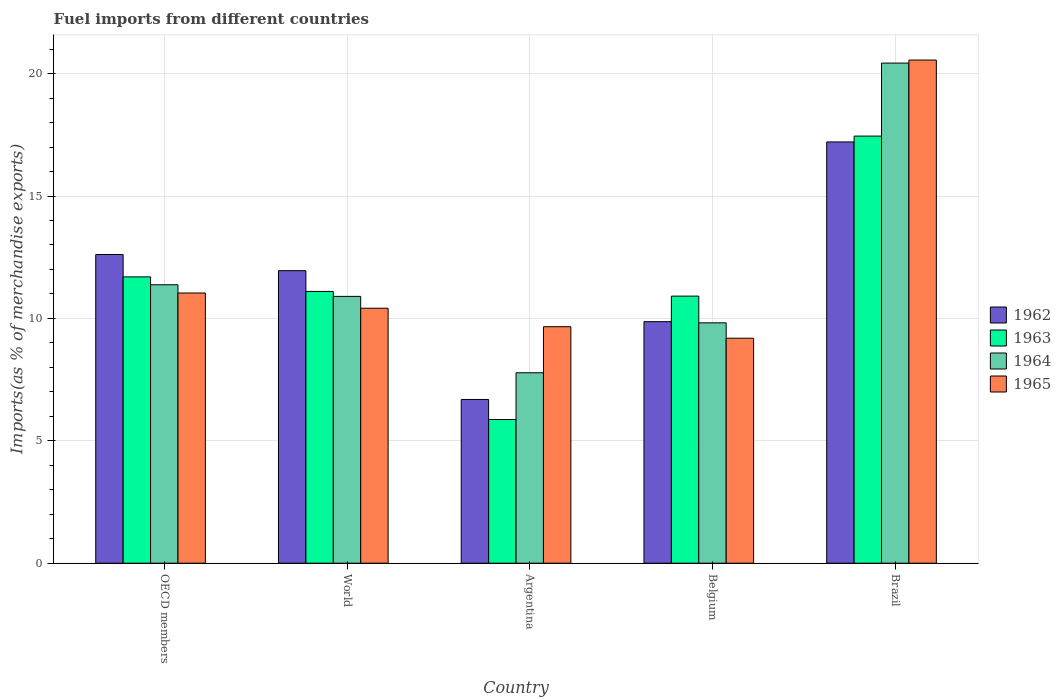How many different coloured bars are there?
Give a very brief answer. 4. Are the number of bars per tick equal to the number of legend labels?
Provide a succinct answer. Yes. Are the number of bars on each tick of the X-axis equal?
Offer a terse response. Yes. How many bars are there on the 3rd tick from the right?
Provide a succinct answer. 4. What is the percentage of imports to different countries in 1962 in Belgium?
Your response must be concise. 9.87. Across all countries, what is the maximum percentage of imports to different countries in 1965?
Provide a succinct answer. 20.55. Across all countries, what is the minimum percentage of imports to different countries in 1965?
Give a very brief answer. 9.19. What is the total percentage of imports to different countries in 1962 in the graph?
Offer a very short reply. 58.33. What is the difference between the percentage of imports to different countries in 1965 in Belgium and that in OECD members?
Your answer should be very brief. -1.85. What is the difference between the percentage of imports to different countries in 1964 in Argentina and the percentage of imports to different countries in 1963 in Brazil?
Keep it short and to the point. -9.67. What is the average percentage of imports to different countries in 1964 per country?
Provide a short and direct response. 12.06. What is the difference between the percentage of imports to different countries of/in 1964 and percentage of imports to different countries of/in 1963 in Belgium?
Your response must be concise. -1.09. What is the ratio of the percentage of imports to different countries in 1964 in OECD members to that in World?
Ensure brevity in your answer.  1.04. Is the difference between the percentage of imports to different countries in 1964 in Argentina and Belgium greater than the difference between the percentage of imports to different countries in 1963 in Argentina and Belgium?
Give a very brief answer. Yes. What is the difference between the highest and the second highest percentage of imports to different countries in 1962?
Give a very brief answer. 5.26. What is the difference between the highest and the lowest percentage of imports to different countries in 1965?
Make the answer very short. 11.36. Is the sum of the percentage of imports to different countries in 1963 in Argentina and Brazil greater than the maximum percentage of imports to different countries in 1964 across all countries?
Make the answer very short. Yes. What does the 3rd bar from the left in Belgium represents?
Give a very brief answer. 1964. What does the 2nd bar from the right in OECD members represents?
Ensure brevity in your answer.  1964. Is it the case that in every country, the sum of the percentage of imports to different countries in 1963 and percentage of imports to different countries in 1962 is greater than the percentage of imports to different countries in 1965?
Offer a very short reply. Yes. How many bars are there?
Make the answer very short. 20. Are all the bars in the graph horizontal?
Provide a succinct answer. No. What is the difference between two consecutive major ticks on the Y-axis?
Make the answer very short. 5. Are the values on the major ticks of Y-axis written in scientific E-notation?
Your answer should be very brief. No. Does the graph contain any zero values?
Your response must be concise. No. Where does the legend appear in the graph?
Your response must be concise. Center right. What is the title of the graph?
Your answer should be compact. Fuel imports from different countries. What is the label or title of the Y-axis?
Your answer should be compact. Imports(as % of merchandise exports). What is the Imports(as % of merchandise exports) in 1962 in OECD members?
Keep it short and to the point. 12.61. What is the Imports(as % of merchandise exports) in 1963 in OECD members?
Your response must be concise. 11.7. What is the Imports(as % of merchandise exports) in 1964 in OECD members?
Provide a short and direct response. 11.37. What is the Imports(as % of merchandise exports) in 1965 in OECD members?
Provide a short and direct response. 11.04. What is the Imports(as % of merchandise exports) of 1962 in World?
Give a very brief answer. 11.95. What is the Imports(as % of merchandise exports) in 1963 in World?
Make the answer very short. 11.1. What is the Imports(as % of merchandise exports) in 1964 in World?
Provide a succinct answer. 10.9. What is the Imports(as % of merchandise exports) of 1965 in World?
Your answer should be very brief. 10.42. What is the Imports(as % of merchandise exports) in 1962 in Argentina?
Give a very brief answer. 6.69. What is the Imports(as % of merchandise exports) in 1963 in Argentina?
Give a very brief answer. 5.87. What is the Imports(as % of merchandise exports) in 1964 in Argentina?
Offer a terse response. 7.78. What is the Imports(as % of merchandise exports) in 1965 in Argentina?
Provide a short and direct response. 9.66. What is the Imports(as % of merchandise exports) of 1962 in Belgium?
Offer a very short reply. 9.87. What is the Imports(as % of merchandise exports) of 1963 in Belgium?
Keep it short and to the point. 10.91. What is the Imports(as % of merchandise exports) of 1964 in Belgium?
Your answer should be very brief. 9.82. What is the Imports(as % of merchandise exports) of 1965 in Belgium?
Offer a very short reply. 9.19. What is the Imports(as % of merchandise exports) of 1962 in Brazil?
Offer a terse response. 17.21. What is the Imports(as % of merchandise exports) in 1963 in Brazil?
Your answer should be compact. 17.45. What is the Imports(as % of merchandise exports) of 1964 in Brazil?
Offer a terse response. 20.43. What is the Imports(as % of merchandise exports) in 1965 in Brazil?
Keep it short and to the point. 20.55. Across all countries, what is the maximum Imports(as % of merchandise exports) of 1962?
Make the answer very short. 17.21. Across all countries, what is the maximum Imports(as % of merchandise exports) in 1963?
Offer a terse response. 17.45. Across all countries, what is the maximum Imports(as % of merchandise exports) in 1964?
Provide a short and direct response. 20.43. Across all countries, what is the maximum Imports(as % of merchandise exports) in 1965?
Offer a very short reply. 20.55. Across all countries, what is the minimum Imports(as % of merchandise exports) in 1962?
Keep it short and to the point. 6.69. Across all countries, what is the minimum Imports(as % of merchandise exports) of 1963?
Keep it short and to the point. 5.87. Across all countries, what is the minimum Imports(as % of merchandise exports) in 1964?
Provide a succinct answer. 7.78. Across all countries, what is the minimum Imports(as % of merchandise exports) in 1965?
Keep it short and to the point. 9.19. What is the total Imports(as % of merchandise exports) in 1962 in the graph?
Your response must be concise. 58.33. What is the total Imports(as % of merchandise exports) in 1963 in the graph?
Give a very brief answer. 57.02. What is the total Imports(as % of merchandise exports) in 1964 in the graph?
Offer a very short reply. 60.3. What is the total Imports(as % of merchandise exports) in 1965 in the graph?
Your answer should be very brief. 60.86. What is the difference between the Imports(as % of merchandise exports) of 1962 in OECD members and that in World?
Your response must be concise. 0.66. What is the difference between the Imports(as % of merchandise exports) in 1963 in OECD members and that in World?
Offer a terse response. 0.59. What is the difference between the Imports(as % of merchandise exports) in 1964 in OECD members and that in World?
Ensure brevity in your answer.  0.48. What is the difference between the Imports(as % of merchandise exports) of 1965 in OECD members and that in World?
Keep it short and to the point. 0.62. What is the difference between the Imports(as % of merchandise exports) in 1962 in OECD members and that in Argentina?
Make the answer very short. 5.92. What is the difference between the Imports(as % of merchandise exports) in 1963 in OECD members and that in Argentina?
Your answer should be very brief. 5.83. What is the difference between the Imports(as % of merchandise exports) in 1964 in OECD members and that in Argentina?
Your response must be concise. 3.59. What is the difference between the Imports(as % of merchandise exports) in 1965 in OECD members and that in Argentina?
Offer a very short reply. 1.38. What is the difference between the Imports(as % of merchandise exports) in 1962 in OECD members and that in Belgium?
Your answer should be compact. 2.74. What is the difference between the Imports(as % of merchandise exports) in 1963 in OECD members and that in Belgium?
Offer a very short reply. 0.79. What is the difference between the Imports(as % of merchandise exports) in 1964 in OECD members and that in Belgium?
Keep it short and to the point. 1.56. What is the difference between the Imports(as % of merchandise exports) in 1965 in OECD members and that in Belgium?
Provide a succinct answer. 1.85. What is the difference between the Imports(as % of merchandise exports) of 1962 in OECD members and that in Brazil?
Make the answer very short. -4.6. What is the difference between the Imports(as % of merchandise exports) of 1963 in OECD members and that in Brazil?
Ensure brevity in your answer.  -5.75. What is the difference between the Imports(as % of merchandise exports) of 1964 in OECD members and that in Brazil?
Make the answer very short. -9.06. What is the difference between the Imports(as % of merchandise exports) in 1965 in OECD members and that in Brazil?
Offer a very short reply. -9.52. What is the difference between the Imports(as % of merchandise exports) in 1962 in World and that in Argentina?
Your answer should be very brief. 5.26. What is the difference between the Imports(as % of merchandise exports) of 1963 in World and that in Argentina?
Make the answer very short. 5.23. What is the difference between the Imports(as % of merchandise exports) of 1964 in World and that in Argentina?
Provide a short and direct response. 3.12. What is the difference between the Imports(as % of merchandise exports) in 1965 in World and that in Argentina?
Keep it short and to the point. 0.76. What is the difference between the Imports(as % of merchandise exports) of 1962 in World and that in Belgium?
Your answer should be very brief. 2.08. What is the difference between the Imports(as % of merchandise exports) in 1963 in World and that in Belgium?
Provide a succinct answer. 0.19. What is the difference between the Imports(as % of merchandise exports) in 1964 in World and that in Belgium?
Make the answer very short. 1.08. What is the difference between the Imports(as % of merchandise exports) of 1965 in World and that in Belgium?
Give a very brief answer. 1.23. What is the difference between the Imports(as % of merchandise exports) in 1962 in World and that in Brazil?
Ensure brevity in your answer.  -5.26. What is the difference between the Imports(as % of merchandise exports) in 1963 in World and that in Brazil?
Ensure brevity in your answer.  -6.34. What is the difference between the Imports(as % of merchandise exports) in 1964 in World and that in Brazil?
Offer a terse response. -9.53. What is the difference between the Imports(as % of merchandise exports) in 1965 in World and that in Brazil?
Provide a succinct answer. -10.14. What is the difference between the Imports(as % of merchandise exports) in 1962 in Argentina and that in Belgium?
Make the answer very short. -3.18. What is the difference between the Imports(as % of merchandise exports) of 1963 in Argentina and that in Belgium?
Provide a short and direct response. -5.04. What is the difference between the Imports(as % of merchandise exports) in 1964 in Argentina and that in Belgium?
Offer a terse response. -2.04. What is the difference between the Imports(as % of merchandise exports) of 1965 in Argentina and that in Belgium?
Provide a succinct answer. 0.47. What is the difference between the Imports(as % of merchandise exports) of 1962 in Argentina and that in Brazil?
Ensure brevity in your answer.  -10.52. What is the difference between the Imports(as % of merchandise exports) of 1963 in Argentina and that in Brazil?
Offer a very short reply. -11.58. What is the difference between the Imports(as % of merchandise exports) in 1964 in Argentina and that in Brazil?
Offer a terse response. -12.65. What is the difference between the Imports(as % of merchandise exports) in 1965 in Argentina and that in Brazil?
Offer a very short reply. -10.89. What is the difference between the Imports(as % of merchandise exports) in 1962 in Belgium and that in Brazil?
Keep it short and to the point. -7.34. What is the difference between the Imports(as % of merchandise exports) of 1963 in Belgium and that in Brazil?
Make the answer very short. -6.54. What is the difference between the Imports(as % of merchandise exports) of 1964 in Belgium and that in Brazil?
Your response must be concise. -10.61. What is the difference between the Imports(as % of merchandise exports) of 1965 in Belgium and that in Brazil?
Give a very brief answer. -11.36. What is the difference between the Imports(as % of merchandise exports) of 1962 in OECD members and the Imports(as % of merchandise exports) of 1963 in World?
Your answer should be very brief. 1.51. What is the difference between the Imports(as % of merchandise exports) in 1962 in OECD members and the Imports(as % of merchandise exports) in 1964 in World?
Ensure brevity in your answer.  1.71. What is the difference between the Imports(as % of merchandise exports) of 1962 in OECD members and the Imports(as % of merchandise exports) of 1965 in World?
Your answer should be very brief. 2.19. What is the difference between the Imports(as % of merchandise exports) of 1963 in OECD members and the Imports(as % of merchandise exports) of 1964 in World?
Ensure brevity in your answer.  0.8. What is the difference between the Imports(as % of merchandise exports) in 1963 in OECD members and the Imports(as % of merchandise exports) in 1965 in World?
Make the answer very short. 1.28. What is the difference between the Imports(as % of merchandise exports) of 1964 in OECD members and the Imports(as % of merchandise exports) of 1965 in World?
Keep it short and to the point. 0.96. What is the difference between the Imports(as % of merchandise exports) in 1962 in OECD members and the Imports(as % of merchandise exports) in 1963 in Argentina?
Offer a very short reply. 6.74. What is the difference between the Imports(as % of merchandise exports) of 1962 in OECD members and the Imports(as % of merchandise exports) of 1964 in Argentina?
Provide a succinct answer. 4.83. What is the difference between the Imports(as % of merchandise exports) of 1962 in OECD members and the Imports(as % of merchandise exports) of 1965 in Argentina?
Ensure brevity in your answer.  2.95. What is the difference between the Imports(as % of merchandise exports) in 1963 in OECD members and the Imports(as % of merchandise exports) in 1964 in Argentina?
Your answer should be very brief. 3.92. What is the difference between the Imports(as % of merchandise exports) of 1963 in OECD members and the Imports(as % of merchandise exports) of 1965 in Argentina?
Ensure brevity in your answer.  2.04. What is the difference between the Imports(as % of merchandise exports) of 1964 in OECD members and the Imports(as % of merchandise exports) of 1965 in Argentina?
Your answer should be very brief. 1.71. What is the difference between the Imports(as % of merchandise exports) in 1962 in OECD members and the Imports(as % of merchandise exports) in 1963 in Belgium?
Keep it short and to the point. 1.7. What is the difference between the Imports(as % of merchandise exports) of 1962 in OECD members and the Imports(as % of merchandise exports) of 1964 in Belgium?
Provide a succinct answer. 2.79. What is the difference between the Imports(as % of merchandise exports) of 1962 in OECD members and the Imports(as % of merchandise exports) of 1965 in Belgium?
Provide a succinct answer. 3.42. What is the difference between the Imports(as % of merchandise exports) of 1963 in OECD members and the Imports(as % of merchandise exports) of 1964 in Belgium?
Offer a very short reply. 1.88. What is the difference between the Imports(as % of merchandise exports) of 1963 in OECD members and the Imports(as % of merchandise exports) of 1965 in Belgium?
Give a very brief answer. 2.51. What is the difference between the Imports(as % of merchandise exports) in 1964 in OECD members and the Imports(as % of merchandise exports) in 1965 in Belgium?
Your answer should be compact. 2.18. What is the difference between the Imports(as % of merchandise exports) in 1962 in OECD members and the Imports(as % of merchandise exports) in 1963 in Brazil?
Ensure brevity in your answer.  -4.84. What is the difference between the Imports(as % of merchandise exports) in 1962 in OECD members and the Imports(as % of merchandise exports) in 1964 in Brazil?
Offer a terse response. -7.82. What is the difference between the Imports(as % of merchandise exports) of 1962 in OECD members and the Imports(as % of merchandise exports) of 1965 in Brazil?
Keep it short and to the point. -7.94. What is the difference between the Imports(as % of merchandise exports) in 1963 in OECD members and the Imports(as % of merchandise exports) in 1964 in Brazil?
Your answer should be very brief. -8.73. What is the difference between the Imports(as % of merchandise exports) in 1963 in OECD members and the Imports(as % of merchandise exports) in 1965 in Brazil?
Your response must be concise. -8.86. What is the difference between the Imports(as % of merchandise exports) in 1964 in OECD members and the Imports(as % of merchandise exports) in 1965 in Brazil?
Offer a very short reply. -9.18. What is the difference between the Imports(as % of merchandise exports) of 1962 in World and the Imports(as % of merchandise exports) of 1963 in Argentina?
Offer a terse response. 6.08. What is the difference between the Imports(as % of merchandise exports) in 1962 in World and the Imports(as % of merchandise exports) in 1964 in Argentina?
Ensure brevity in your answer.  4.17. What is the difference between the Imports(as % of merchandise exports) in 1962 in World and the Imports(as % of merchandise exports) in 1965 in Argentina?
Offer a terse response. 2.29. What is the difference between the Imports(as % of merchandise exports) in 1963 in World and the Imports(as % of merchandise exports) in 1964 in Argentina?
Provide a short and direct response. 3.32. What is the difference between the Imports(as % of merchandise exports) of 1963 in World and the Imports(as % of merchandise exports) of 1965 in Argentina?
Offer a very short reply. 1.44. What is the difference between the Imports(as % of merchandise exports) of 1964 in World and the Imports(as % of merchandise exports) of 1965 in Argentina?
Offer a very short reply. 1.24. What is the difference between the Imports(as % of merchandise exports) of 1962 in World and the Imports(as % of merchandise exports) of 1963 in Belgium?
Provide a short and direct response. 1.04. What is the difference between the Imports(as % of merchandise exports) in 1962 in World and the Imports(as % of merchandise exports) in 1964 in Belgium?
Your answer should be very brief. 2.13. What is the difference between the Imports(as % of merchandise exports) in 1962 in World and the Imports(as % of merchandise exports) in 1965 in Belgium?
Ensure brevity in your answer.  2.76. What is the difference between the Imports(as % of merchandise exports) of 1963 in World and the Imports(as % of merchandise exports) of 1964 in Belgium?
Make the answer very short. 1.28. What is the difference between the Imports(as % of merchandise exports) in 1963 in World and the Imports(as % of merchandise exports) in 1965 in Belgium?
Give a very brief answer. 1.91. What is the difference between the Imports(as % of merchandise exports) of 1964 in World and the Imports(as % of merchandise exports) of 1965 in Belgium?
Ensure brevity in your answer.  1.71. What is the difference between the Imports(as % of merchandise exports) in 1962 in World and the Imports(as % of merchandise exports) in 1963 in Brazil?
Your answer should be very brief. -5.5. What is the difference between the Imports(as % of merchandise exports) of 1962 in World and the Imports(as % of merchandise exports) of 1964 in Brazil?
Offer a very short reply. -8.48. What is the difference between the Imports(as % of merchandise exports) in 1962 in World and the Imports(as % of merchandise exports) in 1965 in Brazil?
Provide a succinct answer. -8.6. What is the difference between the Imports(as % of merchandise exports) in 1963 in World and the Imports(as % of merchandise exports) in 1964 in Brazil?
Your answer should be very brief. -9.33. What is the difference between the Imports(as % of merchandise exports) in 1963 in World and the Imports(as % of merchandise exports) in 1965 in Brazil?
Keep it short and to the point. -9.45. What is the difference between the Imports(as % of merchandise exports) of 1964 in World and the Imports(as % of merchandise exports) of 1965 in Brazil?
Ensure brevity in your answer.  -9.66. What is the difference between the Imports(as % of merchandise exports) of 1962 in Argentina and the Imports(as % of merchandise exports) of 1963 in Belgium?
Your answer should be compact. -4.22. What is the difference between the Imports(as % of merchandise exports) in 1962 in Argentina and the Imports(as % of merchandise exports) in 1964 in Belgium?
Ensure brevity in your answer.  -3.13. What is the difference between the Imports(as % of merchandise exports) in 1962 in Argentina and the Imports(as % of merchandise exports) in 1965 in Belgium?
Offer a very short reply. -2.5. What is the difference between the Imports(as % of merchandise exports) of 1963 in Argentina and the Imports(as % of merchandise exports) of 1964 in Belgium?
Make the answer very short. -3.95. What is the difference between the Imports(as % of merchandise exports) in 1963 in Argentina and the Imports(as % of merchandise exports) in 1965 in Belgium?
Offer a terse response. -3.32. What is the difference between the Imports(as % of merchandise exports) in 1964 in Argentina and the Imports(as % of merchandise exports) in 1965 in Belgium?
Offer a terse response. -1.41. What is the difference between the Imports(as % of merchandise exports) of 1962 in Argentina and the Imports(as % of merchandise exports) of 1963 in Brazil?
Offer a very short reply. -10.76. What is the difference between the Imports(as % of merchandise exports) of 1962 in Argentina and the Imports(as % of merchandise exports) of 1964 in Brazil?
Your response must be concise. -13.74. What is the difference between the Imports(as % of merchandise exports) of 1962 in Argentina and the Imports(as % of merchandise exports) of 1965 in Brazil?
Ensure brevity in your answer.  -13.87. What is the difference between the Imports(as % of merchandise exports) in 1963 in Argentina and the Imports(as % of merchandise exports) in 1964 in Brazil?
Your response must be concise. -14.56. What is the difference between the Imports(as % of merchandise exports) in 1963 in Argentina and the Imports(as % of merchandise exports) in 1965 in Brazil?
Provide a succinct answer. -14.68. What is the difference between the Imports(as % of merchandise exports) in 1964 in Argentina and the Imports(as % of merchandise exports) in 1965 in Brazil?
Make the answer very short. -12.77. What is the difference between the Imports(as % of merchandise exports) in 1962 in Belgium and the Imports(as % of merchandise exports) in 1963 in Brazil?
Make the answer very short. -7.58. What is the difference between the Imports(as % of merchandise exports) in 1962 in Belgium and the Imports(as % of merchandise exports) in 1964 in Brazil?
Ensure brevity in your answer.  -10.56. What is the difference between the Imports(as % of merchandise exports) in 1962 in Belgium and the Imports(as % of merchandise exports) in 1965 in Brazil?
Ensure brevity in your answer.  -10.69. What is the difference between the Imports(as % of merchandise exports) in 1963 in Belgium and the Imports(as % of merchandise exports) in 1964 in Brazil?
Keep it short and to the point. -9.52. What is the difference between the Imports(as % of merchandise exports) in 1963 in Belgium and the Imports(as % of merchandise exports) in 1965 in Brazil?
Provide a short and direct response. -9.64. What is the difference between the Imports(as % of merchandise exports) in 1964 in Belgium and the Imports(as % of merchandise exports) in 1965 in Brazil?
Give a very brief answer. -10.74. What is the average Imports(as % of merchandise exports) in 1962 per country?
Provide a succinct answer. 11.66. What is the average Imports(as % of merchandise exports) in 1963 per country?
Ensure brevity in your answer.  11.4. What is the average Imports(as % of merchandise exports) of 1964 per country?
Offer a terse response. 12.06. What is the average Imports(as % of merchandise exports) in 1965 per country?
Offer a terse response. 12.17. What is the difference between the Imports(as % of merchandise exports) of 1962 and Imports(as % of merchandise exports) of 1963 in OECD members?
Offer a terse response. 0.91. What is the difference between the Imports(as % of merchandise exports) of 1962 and Imports(as % of merchandise exports) of 1964 in OECD members?
Your answer should be very brief. 1.24. What is the difference between the Imports(as % of merchandise exports) of 1962 and Imports(as % of merchandise exports) of 1965 in OECD members?
Your answer should be very brief. 1.57. What is the difference between the Imports(as % of merchandise exports) of 1963 and Imports(as % of merchandise exports) of 1964 in OECD members?
Your response must be concise. 0.32. What is the difference between the Imports(as % of merchandise exports) in 1963 and Imports(as % of merchandise exports) in 1965 in OECD members?
Give a very brief answer. 0.66. What is the difference between the Imports(as % of merchandise exports) of 1964 and Imports(as % of merchandise exports) of 1965 in OECD members?
Provide a succinct answer. 0.34. What is the difference between the Imports(as % of merchandise exports) of 1962 and Imports(as % of merchandise exports) of 1963 in World?
Your response must be concise. 0.85. What is the difference between the Imports(as % of merchandise exports) in 1962 and Imports(as % of merchandise exports) in 1964 in World?
Provide a short and direct response. 1.05. What is the difference between the Imports(as % of merchandise exports) of 1962 and Imports(as % of merchandise exports) of 1965 in World?
Offer a terse response. 1.53. What is the difference between the Imports(as % of merchandise exports) of 1963 and Imports(as % of merchandise exports) of 1964 in World?
Your answer should be very brief. 0.2. What is the difference between the Imports(as % of merchandise exports) of 1963 and Imports(as % of merchandise exports) of 1965 in World?
Provide a short and direct response. 0.69. What is the difference between the Imports(as % of merchandise exports) in 1964 and Imports(as % of merchandise exports) in 1965 in World?
Offer a very short reply. 0.48. What is the difference between the Imports(as % of merchandise exports) in 1962 and Imports(as % of merchandise exports) in 1963 in Argentina?
Keep it short and to the point. 0.82. What is the difference between the Imports(as % of merchandise exports) in 1962 and Imports(as % of merchandise exports) in 1964 in Argentina?
Offer a very short reply. -1.09. What is the difference between the Imports(as % of merchandise exports) in 1962 and Imports(as % of merchandise exports) in 1965 in Argentina?
Give a very brief answer. -2.97. What is the difference between the Imports(as % of merchandise exports) in 1963 and Imports(as % of merchandise exports) in 1964 in Argentina?
Your answer should be very brief. -1.91. What is the difference between the Imports(as % of merchandise exports) in 1963 and Imports(as % of merchandise exports) in 1965 in Argentina?
Offer a terse response. -3.79. What is the difference between the Imports(as % of merchandise exports) in 1964 and Imports(as % of merchandise exports) in 1965 in Argentina?
Keep it short and to the point. -1.88. What is the difference between the Imports(as % of merchandise exports) in 1962 and Imports(as % of merchandise exports) in 1963 in Belgium?
Your answer should be very brief. -1.04. What is the difference between the Imports(as % of merchandise exports) of 1962 and Imports(as % of merchandise exports) of 1964 in Belgium?
Offer a very short reply. 0.05. What is the difference between the Imports(as % of merchandise exports) in 1962 and Imports(as % of merchandise exports) in 1965 in Belgium?
Offer a terse response. 0.68. What is the difference between the Imports(as % of merchandise exports) in 1963 and Imports(as % of merchandise exports) in 1964 in Belgium?
Make the answer very short. 1.09. What is the difference between the Imports(as % of merchandise exports) in 1963 and Imports(as % of merchandise exports) in 1965 in Belgium?
Ensure brevity in your answer.  1.72. What is the difference between the Imports(as % of merchandise exports) in 1964 and Imports(as % of merchandise exports) in 1965 in Belgium?
Provide a succinct answer. 0.63. What is the difference between the Imports(as % of merchandise exports) of 1962 and Imports(as % of merchandise exports) of 1963 in Brazil?
Make the answer very short. -0.24. What is the difference between the Imports(as % of merchandise exports) of 1962 and Imports(as % of merchandise exports) of 1964 in Brazil?
Offer a terse response. -3.22. What is the difference between the Imports(as % of merchandise exports) in 1962 and Imports(as % of merchandise exports) in 1965 in Brazil?
Your response must be concise. -3.35. What is the difference between the Imports(as % of merchandise exports) of 1963 and Imports(as % of merchandise exports) of 1964 in Brazil?
Keep it short and to the point. -2.98. What is the difference between the Imports(as % of merchandise exports) in 1963 and Imports(as % of merchandise exports) in 1965 in Brazil?
Keep it short and to the point. -3.11. What is the difference between the Imports(as % of merchandise exports) in 1964 and Imports(as % of merchandise exports) in 1965 in Brazil?
Offer a very short reply. -0.12. What is the ratio of the Imports(as % of merchandise exports) of 1962 in OECD members to that in World?
Your response must be concise. 1.06. What is the ratio of the Imports(as % of merchandise exports) in 1963 in OECD members to that in World?
Offer a very short reply. 1.05. What is the ratio of the Imports(as % of merchandise exports) in 1964 in OECD members to that in World?
Provide a succinct answer. 1.04. What is the ratio of the Imports(as % of merchandise exports) of 1965 in OECD members to that in World?
Keep it short and to the point. 1.06. What is the ratio of the Imports(as % of merchandise exports) of 1962 in OECD members to that in Argentina?
Provide a short and direct response. 1.89. What is the ratio of the Imports(as % of merchandise exports) in 1963 in OECD members to that in Argentina?
Provide a succinct answer. 1.99. What is the ratio of the Imports(as % of merchandise exports) in 1964 in OECD members to that in Argentina?
Your response must be concise. 1.46. What is the ratio of the Imports(as % of merchandise exports) of 1965 in OECD members to that in Argentina?
Make the answer very short. 1.14. What is the ratio of the Imports(as % of merchandise exports) of 1962 in OECD members to that in Belgium?
Your answer should be compact. 1.28. What is the ratio of the Imports(as % of merchandise exports) in 1963 in OECD members to that in Belgium?
Offer a very short reply. 1.07. What is the ratio of the Imports(as % of merchandise exports) in 1964 in OECD members to that in Belgium?
Give a very brief answer. 1.16. What is the ratio of the Imports(as % of merchandise exports) in 1965 in OECD members to that in Belgium?
Your answer should be very brief. 1.2. What is the ratio of the Imports(as % of merchandise exports) in 1962 in OECD members to that in Brazil?
Provide a succinct answer. 0.73. What is the ratio of the Imports(as % of merchandise exports) in 1963 in OECD members to that in Brazil?
Offer a very short reply. 0.67. What is the ratio of the Imports(as % of merchandise exports) in 1964 in OECD members to that in Brazil?
Offer a very short reply. 0.56. What is the ratio of the Imports(as % of merchandise exports) in 1965 in OECD members to that in Brazil?
Offer a very short reply. 0.54. What is the ratio of the Imports(as % of merchandise exports) in 1962 in World to that in Argentina?
Make the answer very short. 1.79. What is the ratio of the Imports(as % of merchandise exports) in 1963 in World to that in Argentina?
Ensure brevity in your answer.  1.89. What is the ratio of the Imports(as % of merchandise exports) of 1964 in World to that in Argentina?
Keep it short and to the point. 1.4. What is the ratio of the Imports(as % of merchandise exports) in 1965 in World to that in Argentina?
Give a very brief answer. 1.08. What is the ratio of the Imports(as % of merchandise exports) of 1962 in World to that in Belgium?
Your answer should be compact. 1.21. What is the ratio of the Imports(as % of merchandise exports) of 1963 in World to that in Belgium?
Offer a terse response. 1.02. What is the ratio of the Imports(as % of merchandise exports) in 1964 in World to that in Belgium?
Keep it short and to the point. 1.11. What is the ratio of the Imports(as % of merchandise exports) of 1965 in World to that in Belgium?
Make the answer very short. 1.13. What is the ratio of the Imports(as % of merchandise exports) of 1962 in World to that in Brazil?
Keep it short and to the point. 0.69. What is the ratio of the Imports(as % of merchandise exports) in 1963 in World to that in Brazil?
Your response must be concise. 0.64. What is the ratio of the Imports(as % of merchandise exports) of 1964 in World to that in Brazil?
Provide a short and direct response. 0.53. What is the ratio of the Imports(as % of merchandise exports) in 1965 in World to that in Brazil?
Offer a very short reply. 0.51. What is the ratio of the Imports(as % of merchandise exports) in 1962 in Argentina to that in Belgium?
Your response must be concise. 0.68. What is the ratio of the Imports(as % of merchandise exports) of 1963 in Argentina to that in Belgium?
Your response must be concise. 0.54. What is the ratio of the Imports(as % of merchandise exports) in 1964 in Argentina to that in Belgium?
Keep it short and to the point. 0.79. What is the ratio of the Imports(as % of merchandise exports) in 1965 in Argentina to that in Belgium?
Give a very brief answer. 1.05. What is the ratio of the Imports(as % of merchandise exports) of 1962 in Argentina to that in Brazil?
Provide a succinct answer. 0.39. What is the ratio of the Imports(as % of merchandise exports) in 1963 in Argentina to that in Brazil?
Your answer should be very brief. 0.34. What is the ratio of the Imports(as % of merchandise exports) of 1964 in Argentina to that in Brazil?
Offer a very short reply. 0.38. What is the ratio of the Imports(as % of merchandise exports) of 1965 in Argentina to that in Brazil?
Provide a short and direct response. 0.47. What is the ratio of the Imports(as % of merchandise exports) of 1962 in Belgium to that in Brazil?
Your answer should be very brief. 0.57. What is the ratio of the Imports(as % of merchandise exports) of 1963 in Belgium to that in Brazil?
Offer a very short reply. 0.63. What is the ratio of the Imports(as % of merchandise exports) in 1964 in Belgium to that in Brazil?
Make the answer very short. 0.48. What is the ratio of the Imports(as % of merchandise exports) of 1965 in Belgium to that in Brazil?
Your response must be concise. 0.45. What is the difference between the highest and the second highest Imports(as % of merchandise exports) in 1962?
Keep it short and to the point. 4.6. What is the difference between the highest and the second highest Imports(as % of merchandise exports) in 1963?
Provide a short and direct response. 5.75. What is the difference between the highest and the second highest Imports(as % of merchandise exports) in 1964?
Provide a succinct answer. 9.06. What is the difference between the highest and the second highest Imports(as % of merchandise exports) of 1965?
Offer a terse response. 9.52. What is the difference between the highest and the lowest Imports(as % of merchandise exports) in 1962?
Offer a terse response. 10.52. What is the difference between the highest and the lowest Imports(as % of merchandise exports) of 1963?
Offer a terse response. 11.58. What is the difference between the highest and the lowest Imports(as % of merchandise exports) in 1964?
Your response must be concise. 12.65. What is the difference between the highest and the lowest Imports(as % of merchandise exports) in 1965?
Keep it short and to the point. 11.36. 